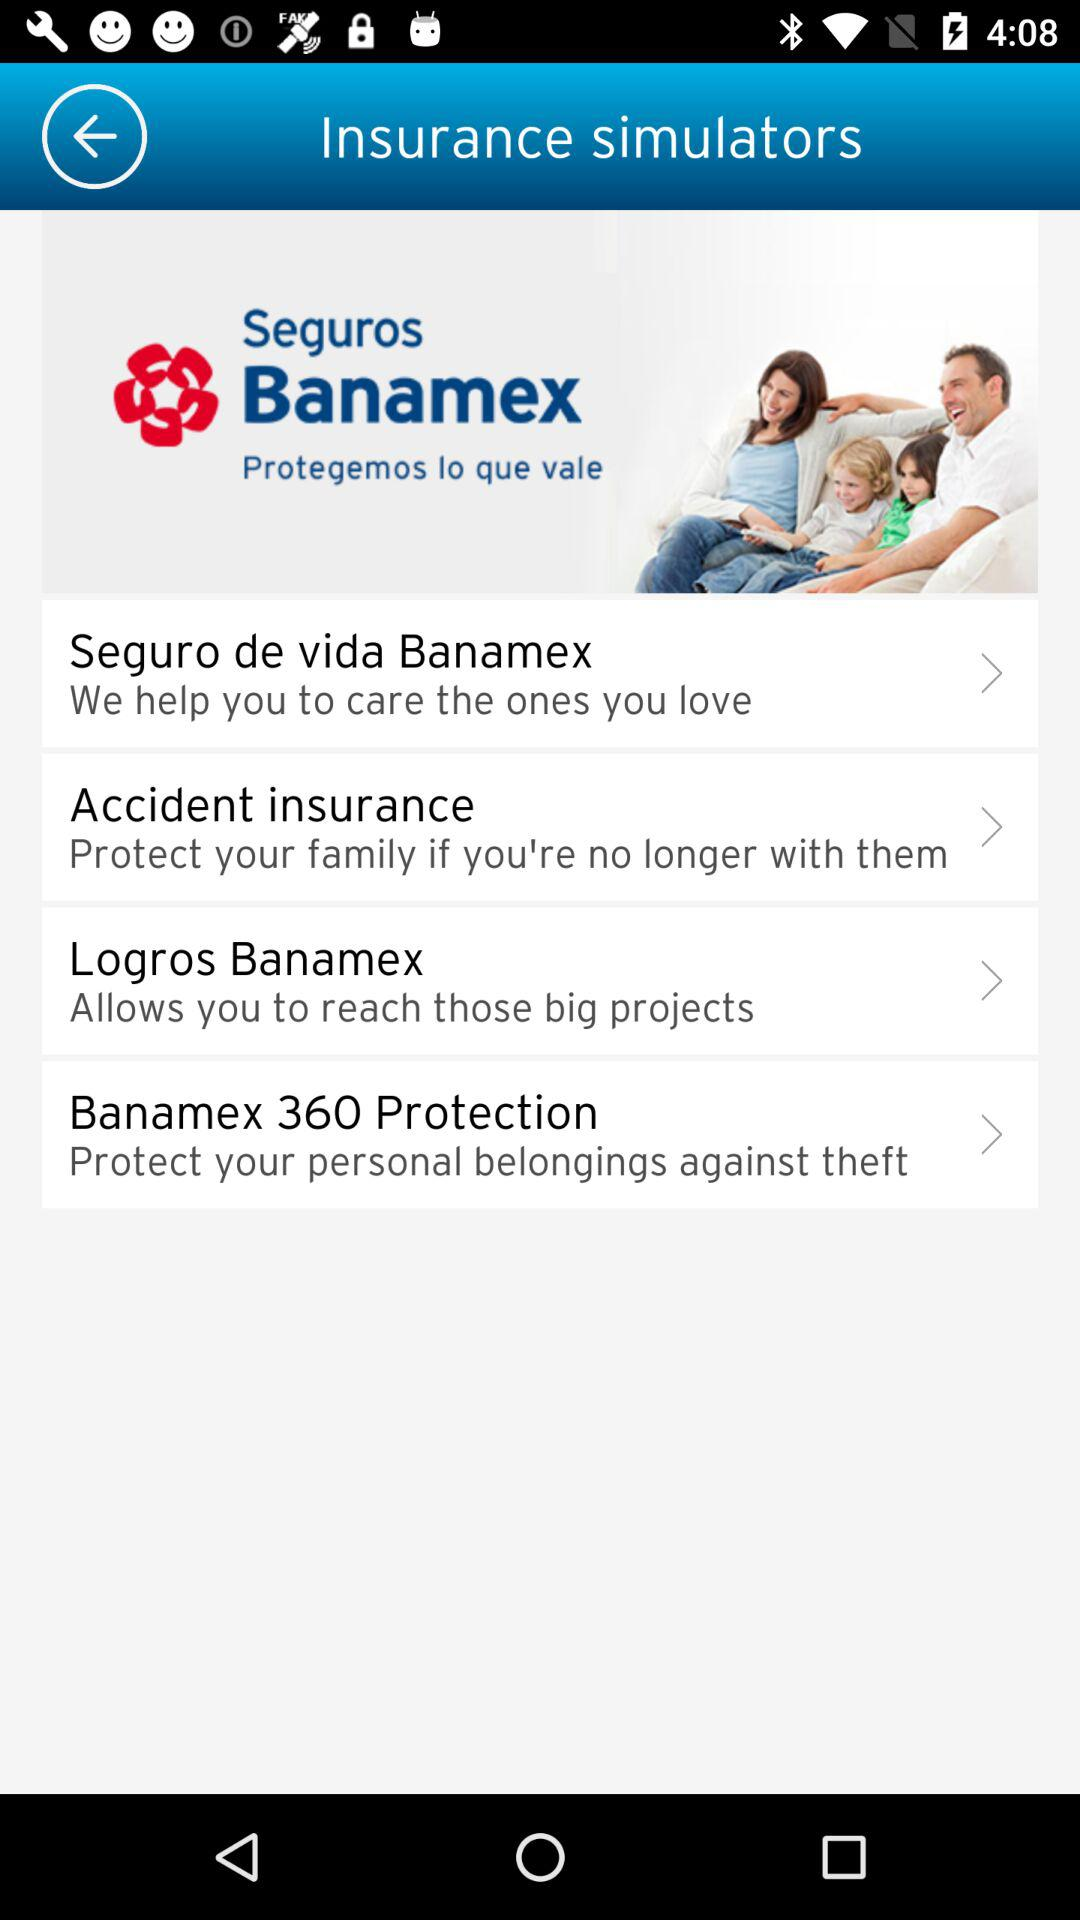How many insurances are there in total?
Answer the question using a single word or phrase. 4 